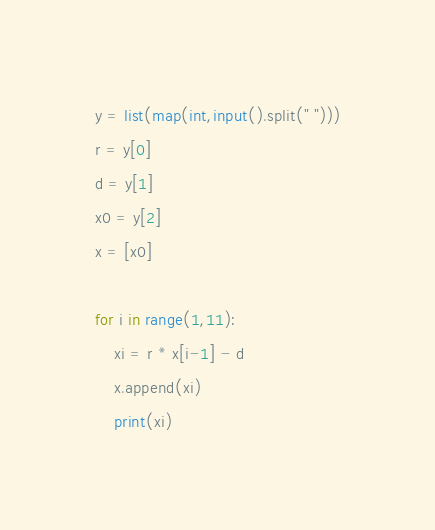<code> <loc_0><loc_0><loc_500><loc_500><_Python_>y = list(map(int,input().split(" ")))
r = y[0]
d = y[1]
x0 = y[2]
x = [x0]

for i in range(1,11):
    xi = r * x[i-1] - d
    x.append(xi)
    print(xi)</code> 